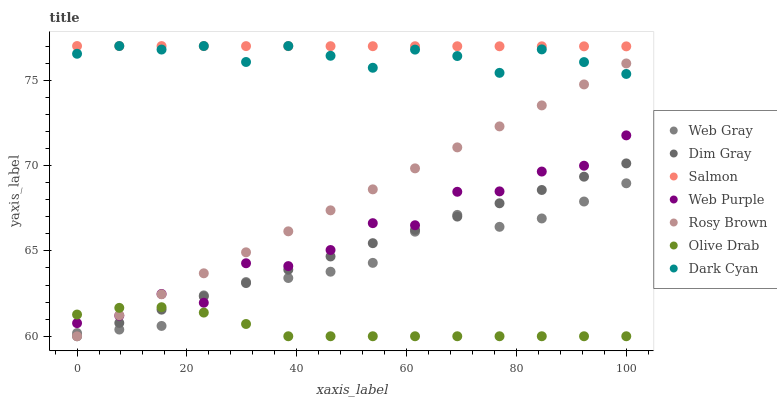Does Olive Drab have the minimum area under the curve?
Answer yes or no. Yes. Does Salmon have the maximum area under the curve?
Answer yes or no. Yes. Does Rosy Brown have the minimum area under the curve?
Answer yes or no. No. Does Rosy Brown have the maximum area under the curve?
Answer yes or no. No. Is Dim Gray the smoothest?
Answer yes or no. Yes. Is Web Purple the roughest?
Answer yes or no. Yes. Is Rosy Brown the smoothest?
Answer yes or no. No. Is Rosy Brown the roughest?
Answer yes or no. No. Does Dim Gray have the lowest value?
Answer yes or no. Yes. Does Salmon have the lowest value?
Answer yes or no. No. Does Dark Cyan have the highest value?
Answer yes or no. Yes. Does Rosy Brown have the highest value?
Answer yes or no. No. Is Olive Drab less than Dark Cyan?
Answer yes or no. Yes. Is Salmon greater than Web Gray?
Answer yes or no. Yes. Does Olive Drab intersect Dim Gray?
Answer yes or no. Yes. Is Olive Drab less than Dim Gray?
Answer yes or no. No. Is Olive Drab greater than Dim Gray?
Answer yes or no. No. Does Olive Drab intersect Dark Cyan?
Answer yes or no. No. 